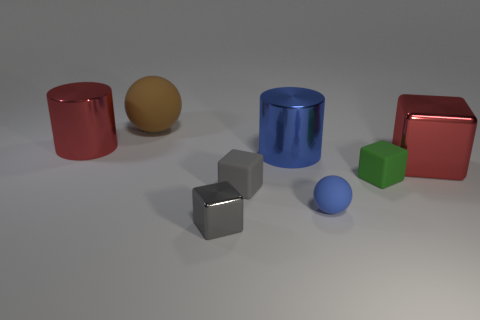If the light source in the image were to be shifted, which object would cast the longest shadow? The object that would cast the longest shadow would depend on the angle and proximity of the light source to the objects. However, in general, the tallest objects tend to cast longer shadows. In this case, the cyan cylinder, being among the tallest objects in the image, would likely cast the longest shadow, especially if the light source is at or near the level of the objects and at a significant angle. 